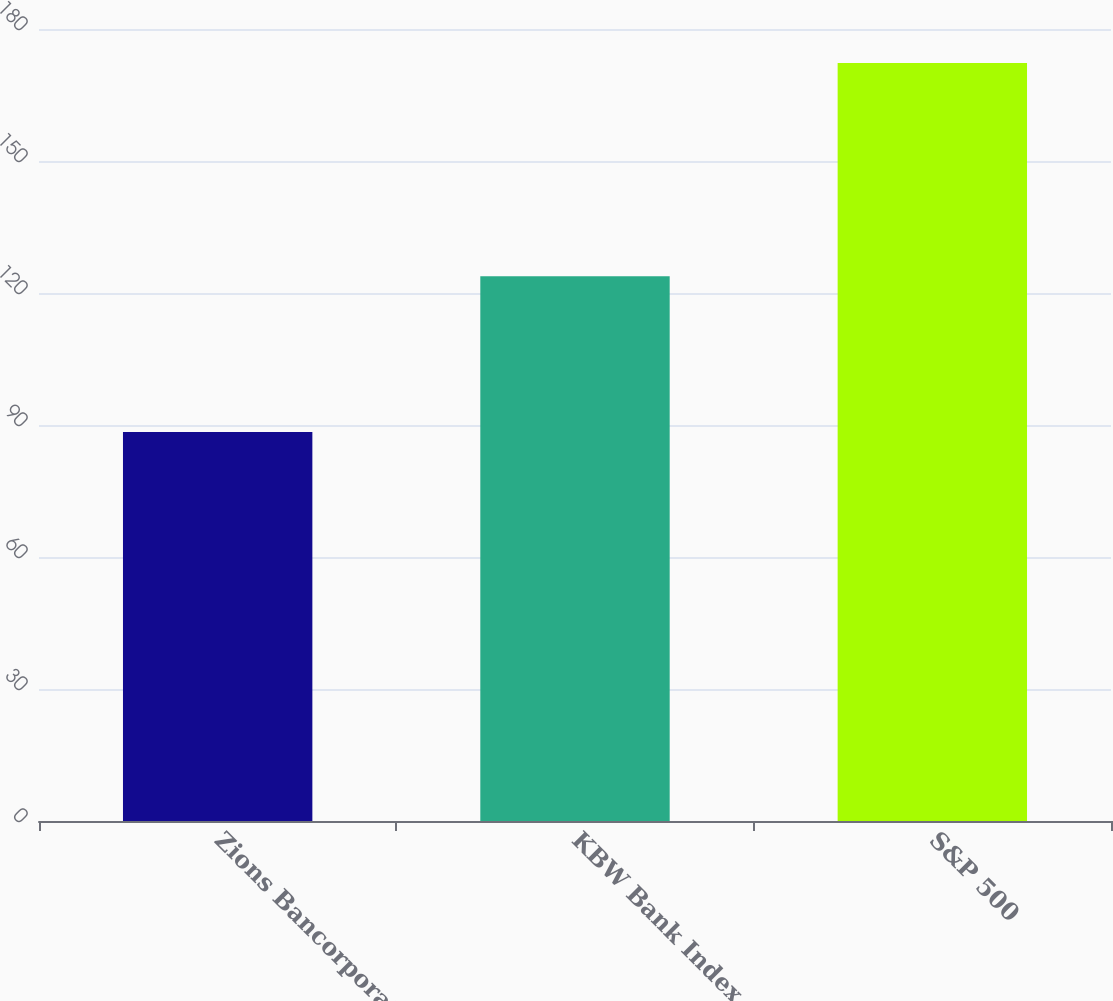Convert chart to OTSL. <chart><loc_0><loc_0><loc_500><loc_500><bar_chart><fcel>Zions Bancorporation<fcel>KBW Bank Index<fcel>S&P 500<nl><fcel>88.4<fcel>123.8<fcel>172.3<nl></chart> 